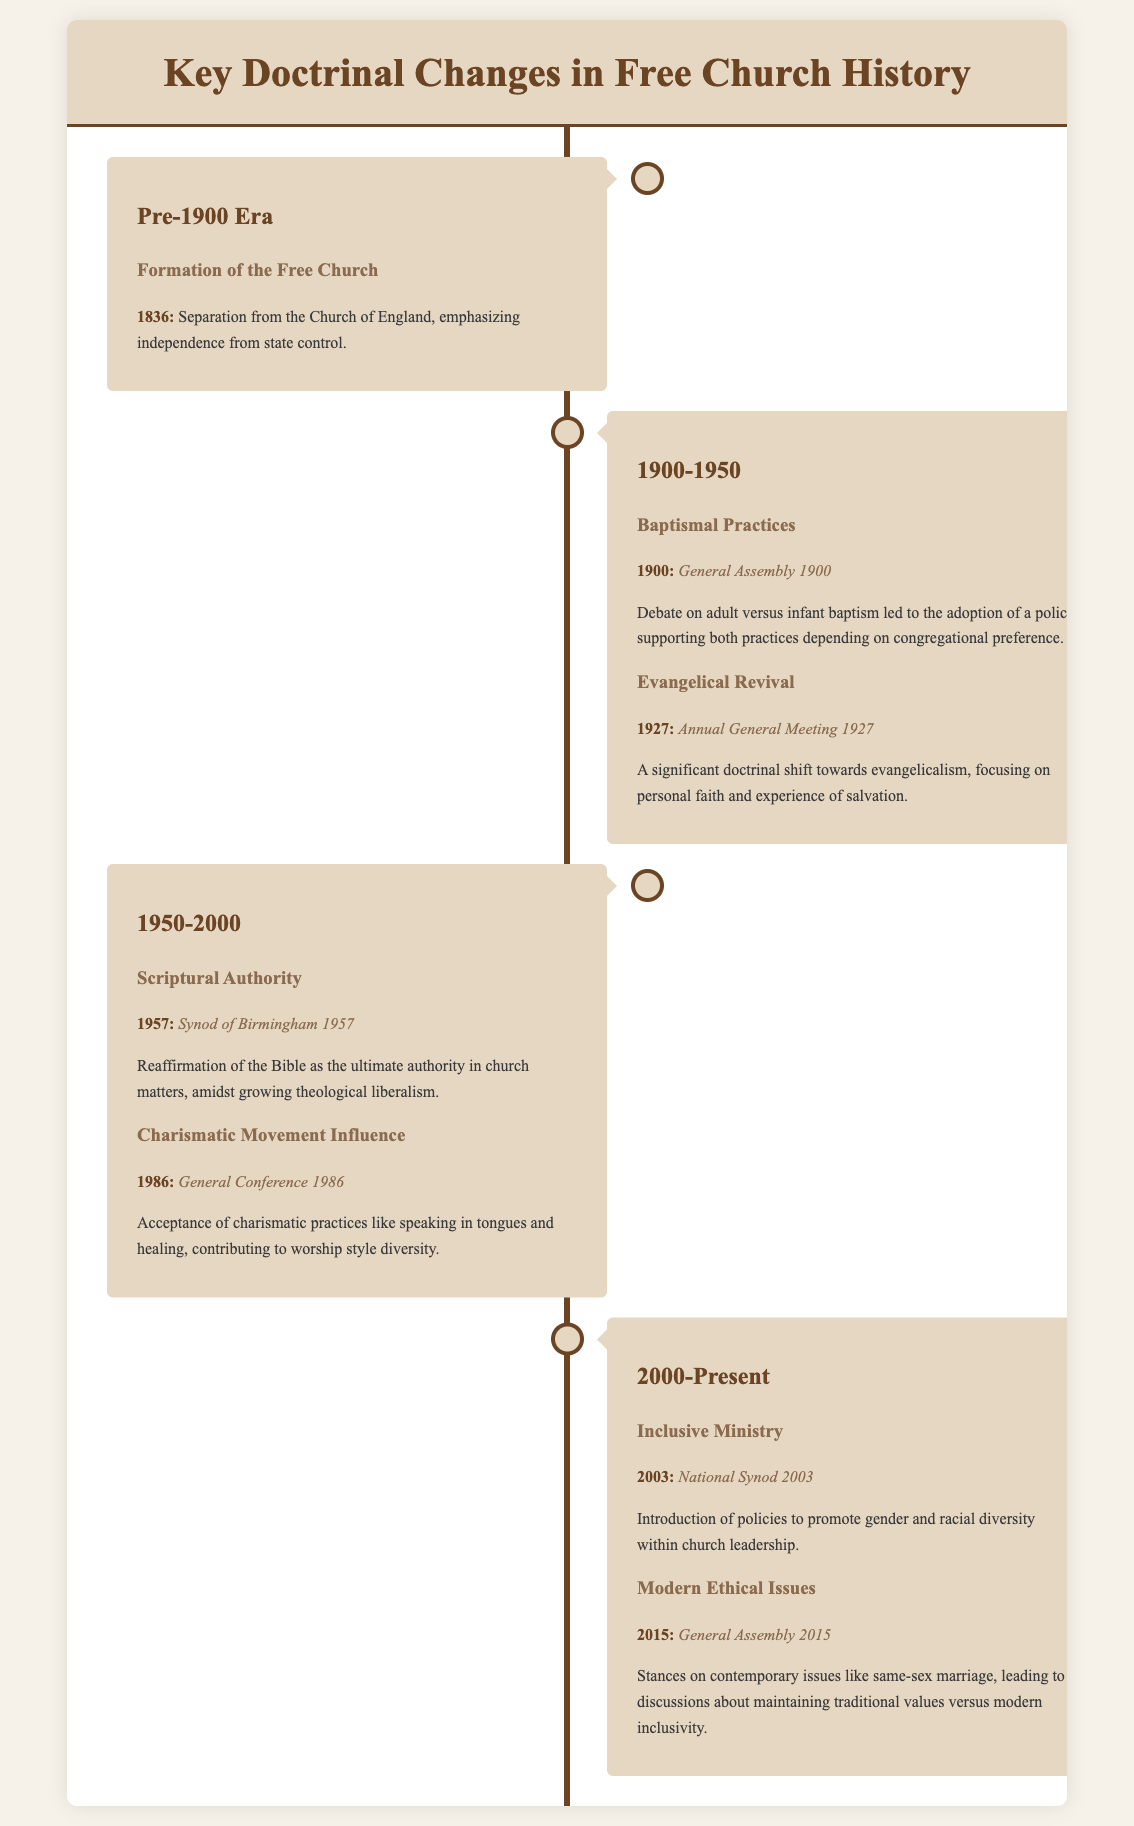What year did the Free Church separate from the Church of England? The document states the separation occurred in 1836, marking the formation of the Free Church.
Answer: 1836 What doctrinal shift occurred in 1927? In 1927, the Annual General Meeting led to a significant shift towards evangelicalism, focusing on personal faith and experience of salvation.
Answer: Evangelical Revival Which synod reaffirmed the Bible's ultimate authority in 1957? The Synod of Birmingham in 1957 reaffirmed the Bible as the ultimate authority amidst growing theological liberalism.
Answer: Synod of Birmingham 1957 What was introduced in 2003 regarding church leadership? The National Synod 2003 introduced policies to promote gender and racial diversity within church leadership.
Answer: Inclusive Ministry Which synod discussed contemporary issues like same-sex marriage in 2015? The General Assembly in 2015 addressed contemporary issues such as same-sex marriage, leading to discussions about values.
Answer: General Assembly 2015 What practice was accepted during the General Conference in 1986? The General Conference in 1986 accepted charismatic practices, including speaking in tongues and healing, influencing worship style.
Answer: Charismatic Movement Influence How many key doctrinal eras are detailed in the infographic? The document outlines four key doctrinal eras: Pre-1900 Era, 1900-1950, 1950-2000, and 2000-Present.
Answer: Four What title is given to the document? The title of the document is "Key Doctrinal Changes in Free Church History."
Answer: Key Doctrinal Changes in Free Church History 